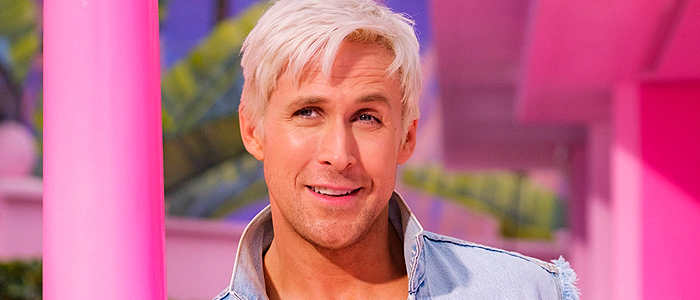What do you see happening in this image? The image features a man with a friendly expression, standing against a colorful background of pink and yellow. He is dressed in a casual light blue denim jacket paired with a white shirt, which suits the vibrant setting. His blonde hair is styled in a fashionable manner, contrasting sharply with the hues behind him. The man is positioned off-center to the right, gazing directly at the camera, which adds a personal touch to the shot, evoking a sense of ease and approachability. 